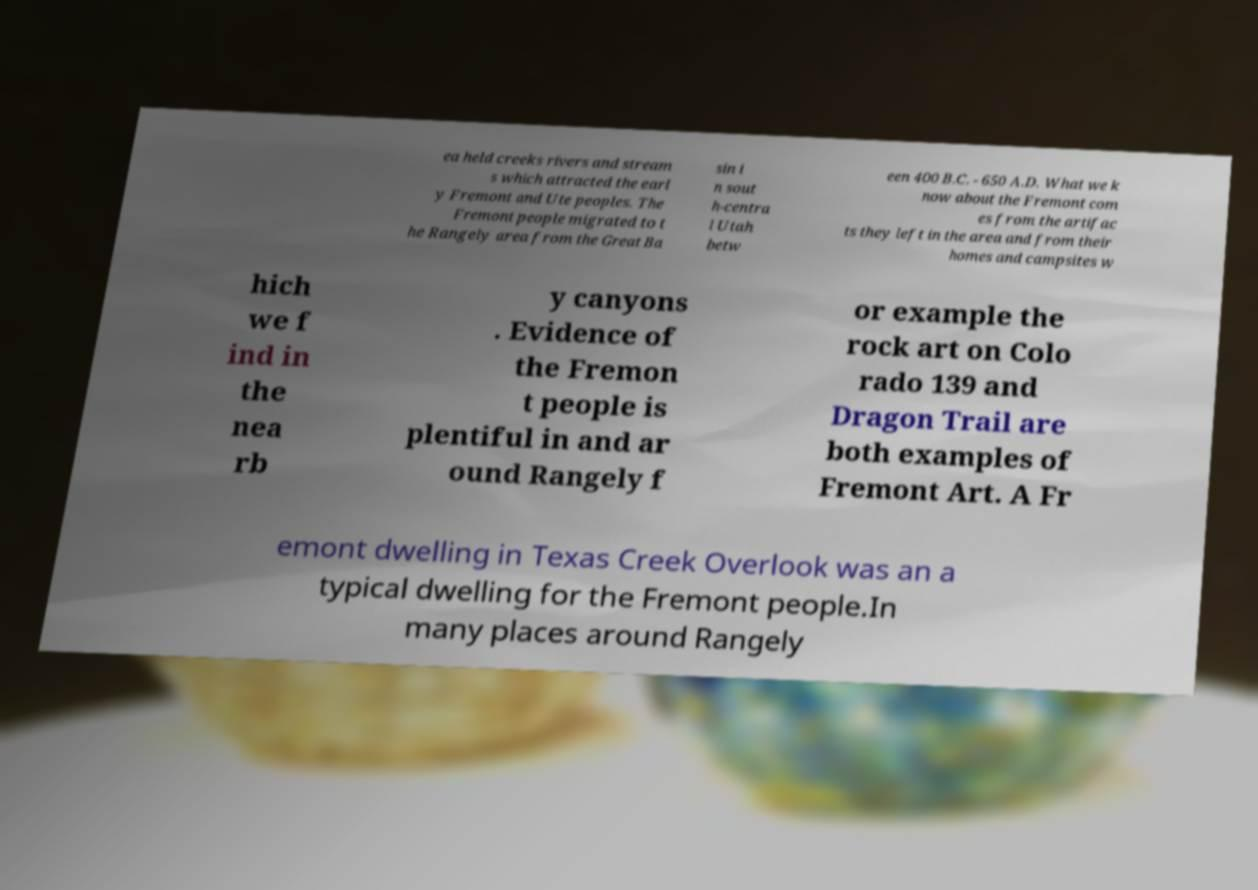Please identify and transcribe the text found in this image. ea held creeks rivers and stream s which attracted the earl y Fremont and Ute peoples. The Fremont people migrated to t he Rangely area from the Great Ba sin i n sout h-centra l Utah betw een 400 B.C. - 650 A.D. What we k now about the Fremont com es from the artifac ts they left in the area and from their homes and campsites w hich we f ind in the nea rb y canyons . Evidence of the Fremon t people is plentiful in and ar ound Rangely f or example the rock art on Colo rado 139 and Dragon Trail are both examples of Fremont Art. A Fr emont dwelling in Texas Creek Overlook was an a typical dwelling for the Fremont people.In many places around Rangely 